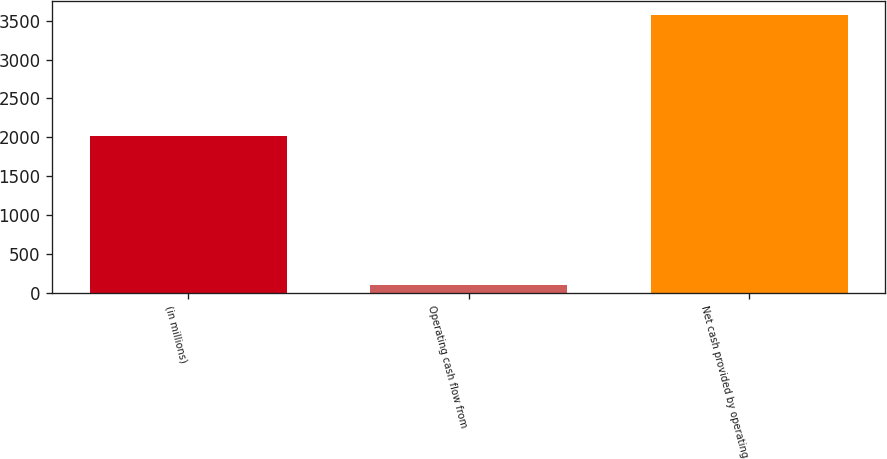Convert chart. <chart><loc_0><loc_0><loc_500><loc_500><bar_chart><fcel>(in millions)<fcel>Operating cash flow from<fcel>Net cash provided by operating<nl><fcel>2015<fcel>97<fcel>3579.4<nl></chart> 